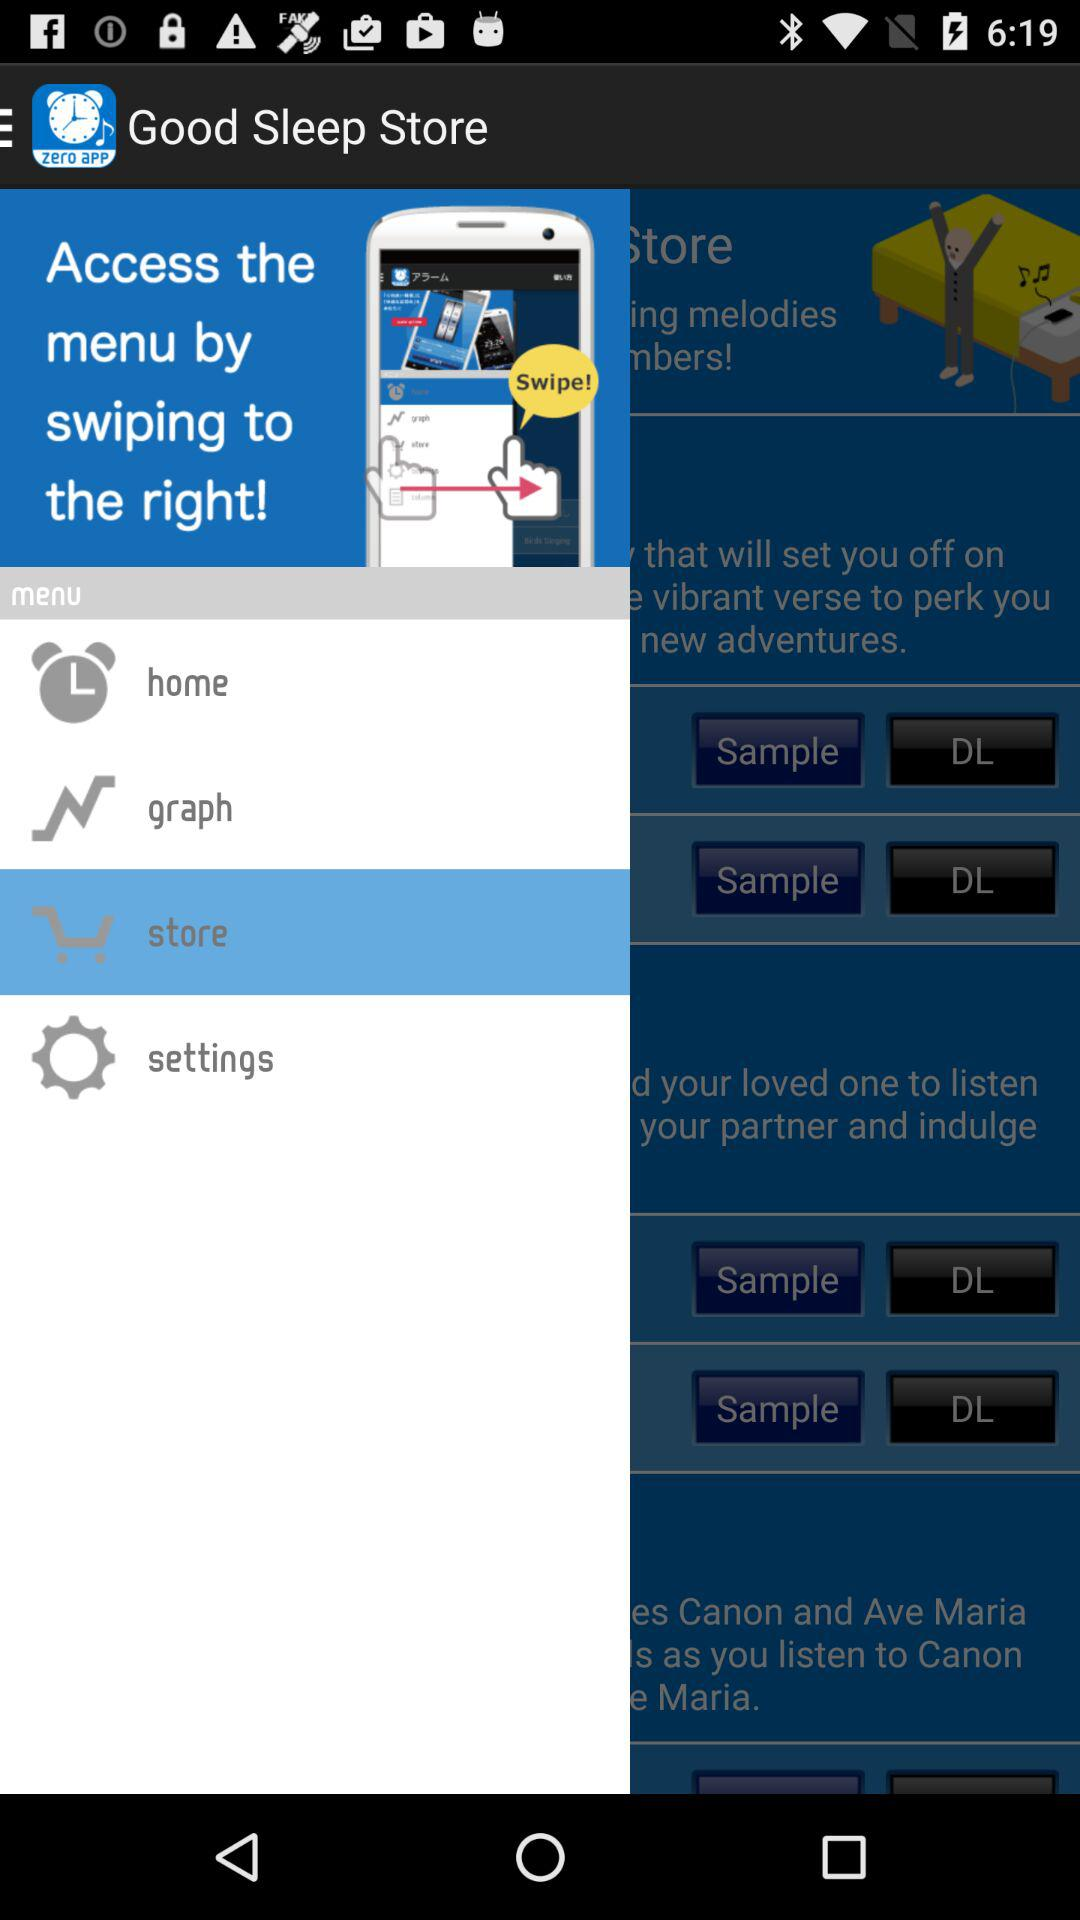What is the name of the application? The name of the application is "Good Night's Sleep Alarm". 